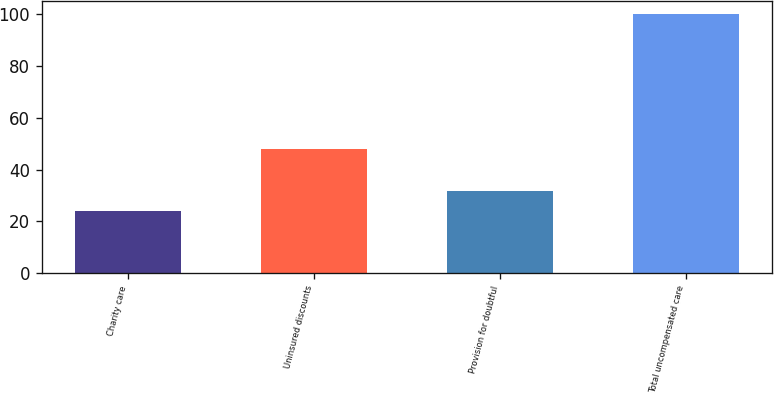Convert chart to OTSL. <chart><loc_0><loc_0><loc_500><loc_500><bar_chart><fcel>Charity care<fcel>Uninsured discounts<fcel>Provision for doubtful<fcel>Total uncompensated care<nl><fcel>24<fcel>48<fcel>31.6<fcel>100<nl></chart> 